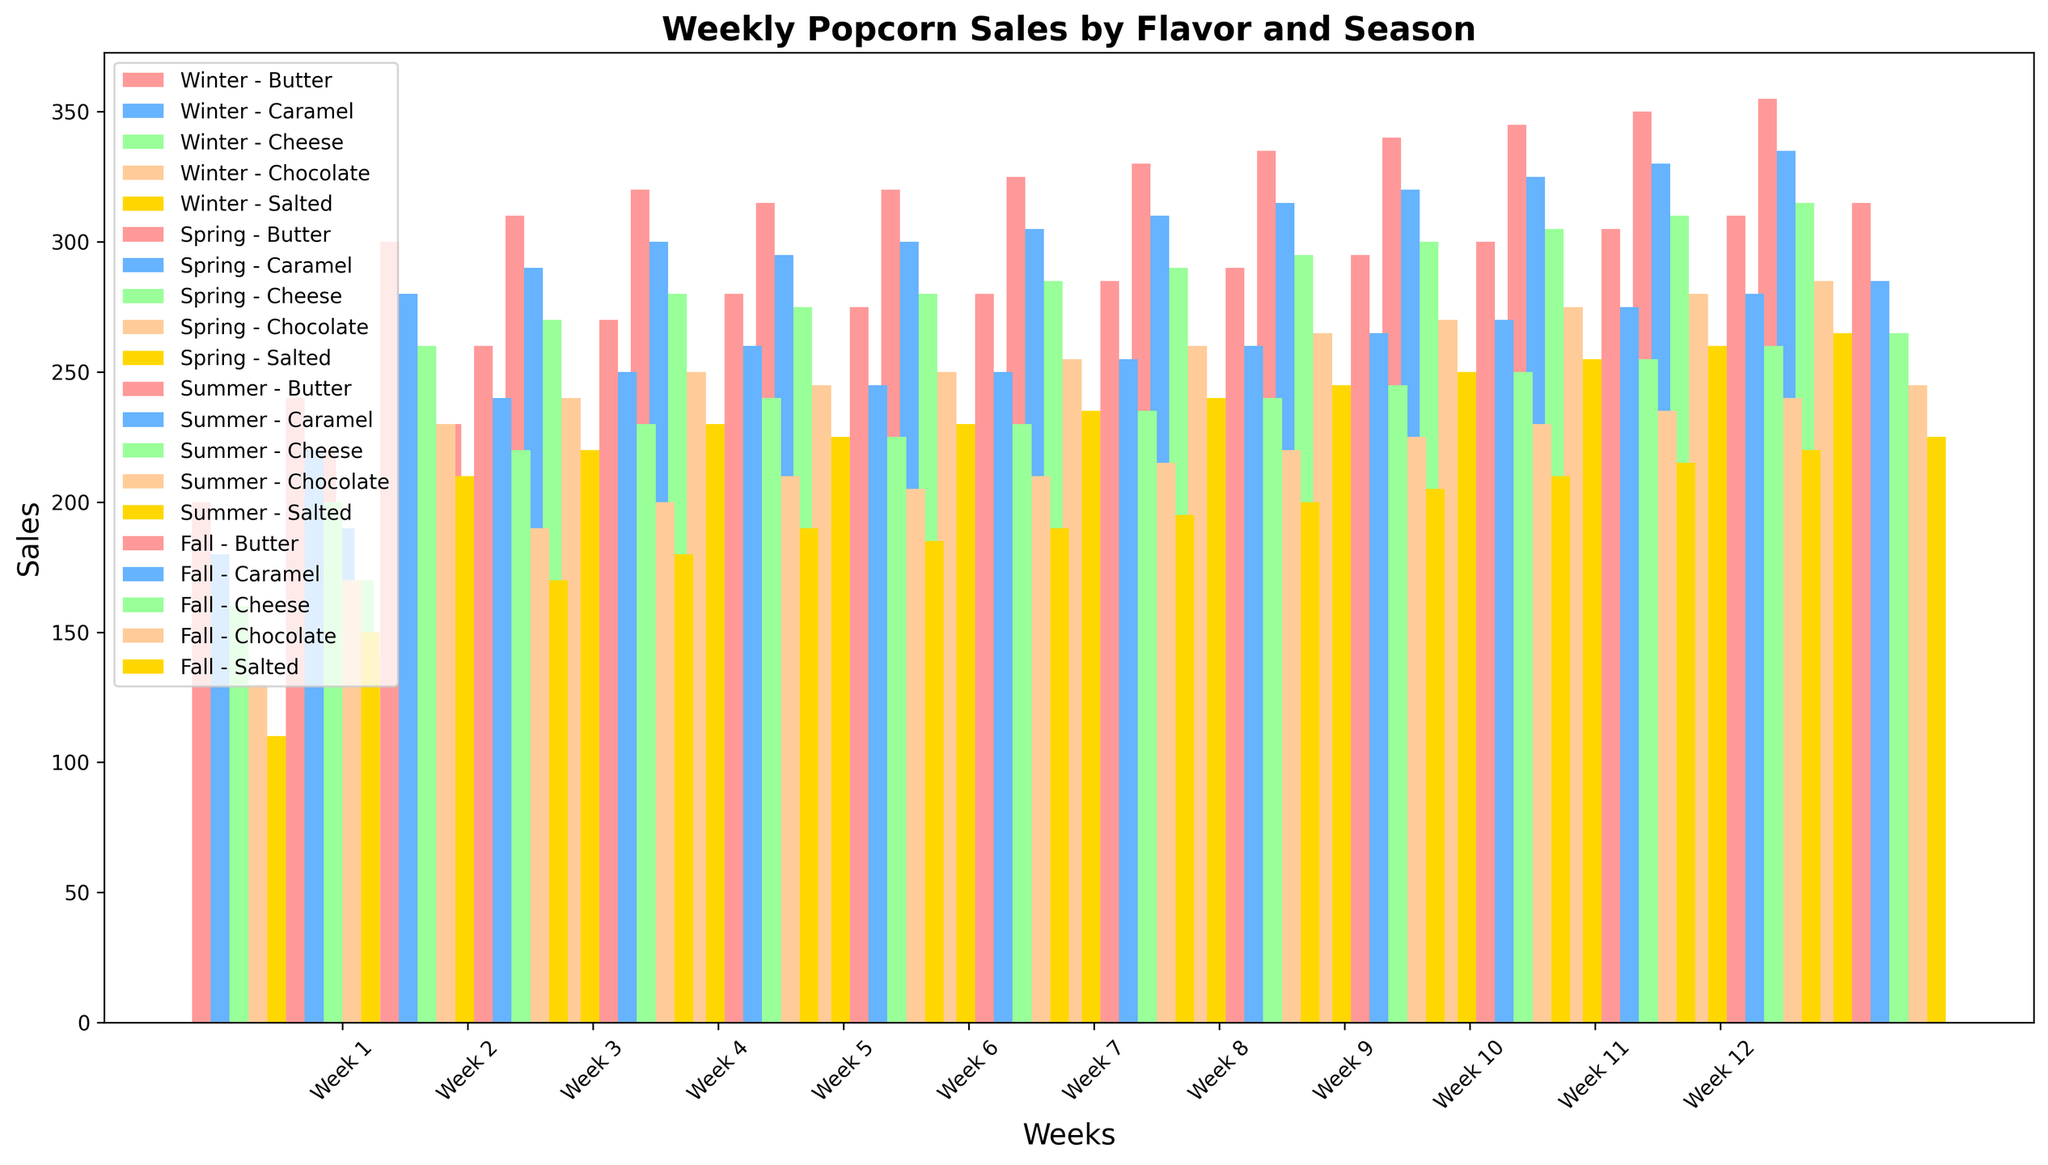What is the overall trend of sales for Butter flavor across all seasons? The Butter flavor shows an increasing trend in sales across all seasons. In Winter, the sales start at 200 in Week 1 and gradually increase to 245 by Week 12. In Spring, it starts at 240 and increases to 295. In Summer, it begins at 300 and rises to 355. In Fall, it starts at 260 and increases to 315. The consistent increase in sales across all seasons indicates that Butter flavor is consistently popular and sees rising demand throughout the weeks.
Answer: Increasing trend Which season has the highest weekly sales for Caramel flavor? To determine the season with the highest weekly sales for Caramel flavor, look at the tallest bars for Caramel flavor in each season across the weeks. In Winter, the sales peak at 230 in Week 12. In Spring, it reaches 270, also in Week 12. In Summer, the sales are highest in Week 12 at 335. In Fall, it reaches 285. Therefore, Summer has the highest weekly sales for Caramel flavor, peaking at 335 in Week 12.
Answer: Summer During which week did the sales for Cheese flavor in Winter and Spring sum to the highest total? To find the week with the highest combined sales of Cheese flavor in Winter and Spring, sum the corresponding weekly sales from both seasons. For Week 1, the sum is 160 (Winter) + 200 (Spring) = 360, and so on for each week. The week with the highest combined total is Week 12, with 215 (Winter) + 250 (Spring) = 465.
Answer: Week 12 Which two popcorn flavors have the closest sales figures in Week 5 during Summer? To find the two flavors with the closest sales figures in Week 5 of Summer, compare the sales of all flavors in that week. Butter has 320, Caramel 300, Cheese 280, Chocolate 250, and Salted 230. The closest figures are between Cheese (280) and Chocolate (250), with a difference of only 30 units.
Answer: Cheese and Chocolate Is the average weekly sales of Salted flavor in Fall higher or lower compared to Winter? Calculate the average weekly sales for Salted flavor in both Fall and Winter. For Fall, sum the sales from Week 1 to 12 (170+180+190+185+190+195+200+205+210+215+220+225 = 2385), and divide by 12, resulting in 198.75. For Winter, sum the sales (110+120+130+125+130+135+140+145+150+155+160+165 = 1665), and divide by 12, resulting in 138.75. Therefore, the average weekly sales in Fall (198.75) is higher than in Winter (138.75).
Answer: Higher Which flavor had the lowest starting sales in Winter, and what were the sales figures? To identify the flavor with the lowest starting sales in Winter, compare the sales figures for Week 1 across all flavors. The sales are: Butter (200), Caramel (180), Cheese (160), Chocolate (130), and Salted (110). Salted had the lowest starting sales with a figure of 110.
Answer: Salted, 110 How does the sales pattern of Chocolate flavor in Winter compare to Spring? In Winter, Chocolate flavor sales start at 130 in Week 1 and rise steadily to 185 in Week 12. In Spring, it starts higher at 170 in Week 1 and also increases steadily to 220 in Week 12. The pattern of steady increase is consistent in both seasons, but the starting and ending sales figures are higher in Spring than in Winter (170 to 220 in Spring, compared to 130 to185 in Winter).
Answer: Steady increase, higher in Spring In which week did Butter flavor achieve its peak sales in Summer? To find when Butter flavor achieved its peak sales during Summer, examine the sales figures for each week. The sales increase gradually from 300 in Week 1 to a peak of 355 by Week 12. Thus, the peak sales for Butter flavor in Summer occur in Week 12.
Answer: Week 12 